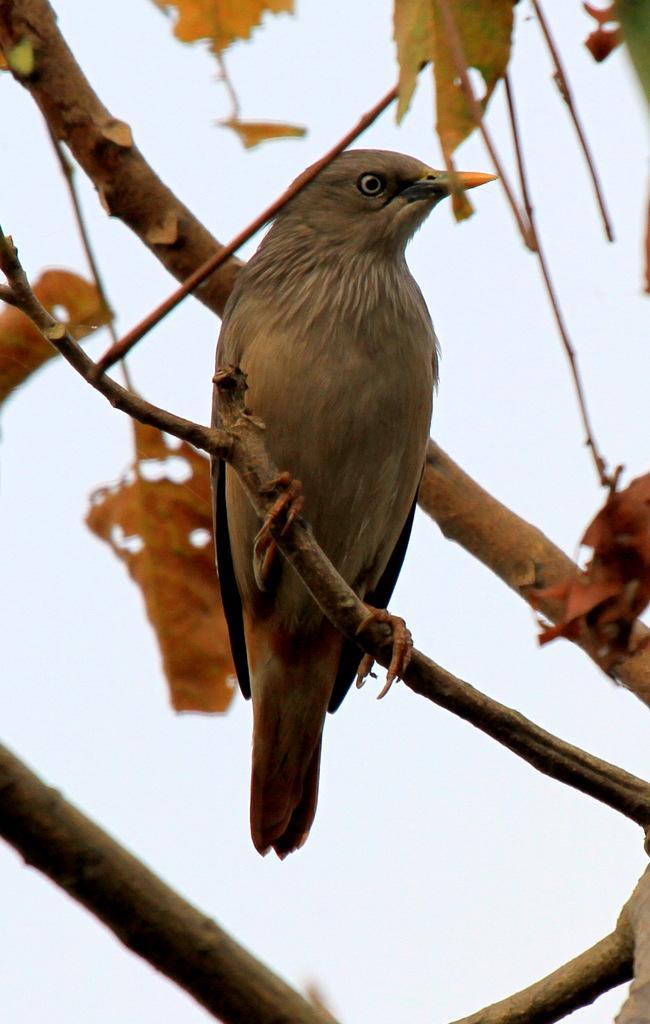Please provide a concise description of this image. In this image there is a bird standing and there are leaves and there are tree trunks. 